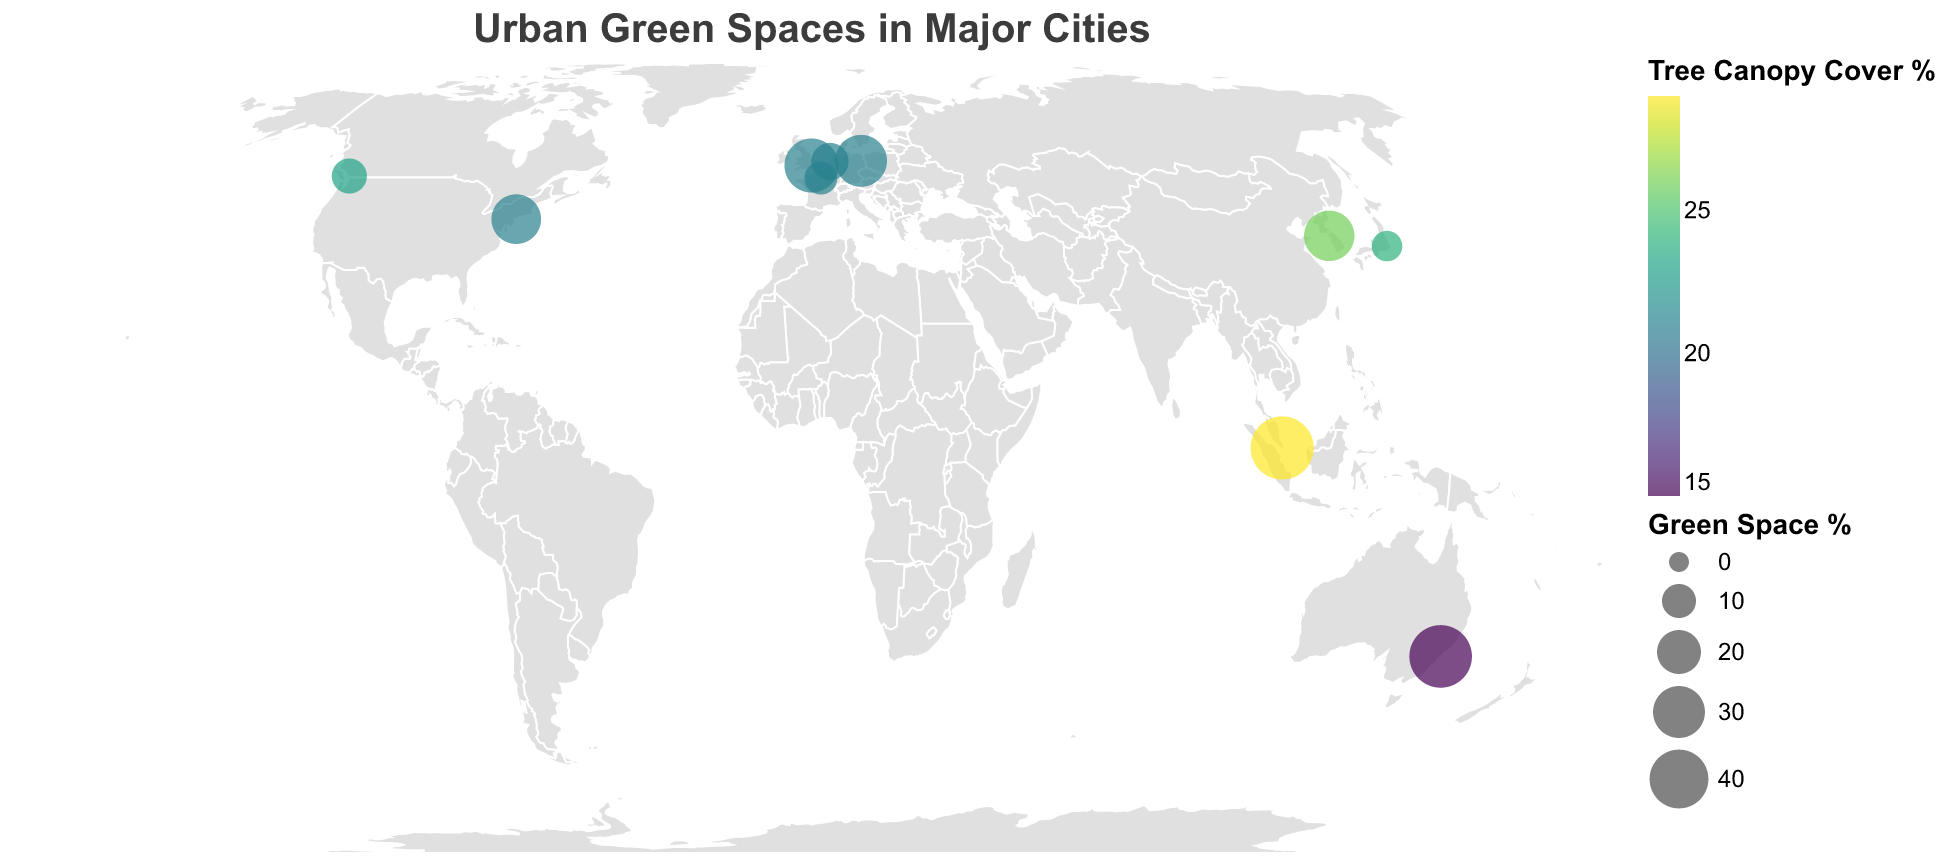What is the title of the figure? The title of the figure is typically found at the top of the plot. In this case, it reads "Urban Green Spaces in Major Cities".
Answer: Urban Green Spaces in Major Cities Which city has the highest percentage of green space? By referring to the size of the circles, the city with the largest circle represents the highest percentage of green space. The largest circle is associated with Singapore.
Answer: Singapore What city has the highest tree canopy cover percentage and what is that percentage? By looking at the color intensity of the circles, the darkest color indicates the highest tree canopy cover. Singapore has the darkest color, indicating the highest tree canopy cover, which is 29%.
Answer: Singapore, 29% Which city has the least number of parks? The tooltip information shows the number of parks for each city. The city with the smallest Parks_Count is Amsterdam with 30 parks.
Answer: Amsterdam Which two cities have an equal tree canopy cover percentage? By looking at the color similar similarity, both New York City and London have a tree canopy cover percentage of 21%.
Answer: New York City and London How much more is the percentage of green space in London compared to New York City? London has 33% green space while New York City has 27%. Subtracting the two values gives 6%.
Answer: 6% Of the cities located in the Northern Hemisphere, which has the lowest green space percentage? The Northern Hemisphere cities are New York City, London, Tokyo, Paris, Vancouver, Berlin, Amsterdam, and Seoul. Among these, Tokyo has the lowest green space percentage at 7%.
Answer: Tokyo What is the average tree canopy cover percentage among all the listed cities? To find the average, sum the tree canopy cover percentages (21 + 21 + 24 + 21 + 29 + 15 + 23 + 21 + 21 + 26) and divide by the number of cities (10). This equals 222/10 = 22.2%.
Answer: 22.2% How does the green space percentage in Sydney compare to that in Singapore? Sydney has a green space percentage of 46%, and Singapore has 47%. The green space percentage in Sydney is 1% less than in Singapore.
Answer: 1% less What is the total number of parks in European cities listed on the plot? The European cities listed are London, Paris, Berlin, and Amsterdam. Summing their Parks_Count values, we get 3000 (London) + 400 (Paris) + 2500 (Berlin) + 30 (Amsterdam) = 5930.
Answer: 5930 